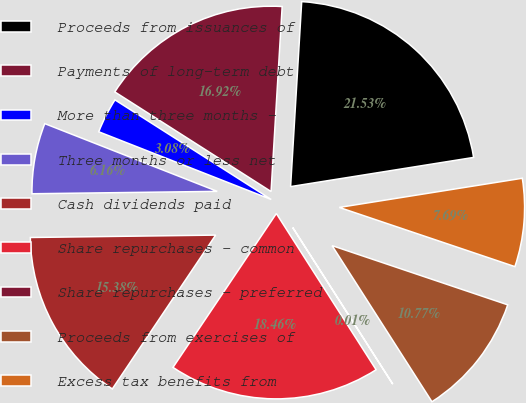<chart> <loc_0><loc_0><loc_500><loc_500><pie_chart><fcel>Proceeds from issuances of<fcel>Payments of long-term debt<fcel>More than three months -<fcel>Three months or less net<fcel>Cash dividends paid<fcel>Share repurchases - common<fcel>Share repurchases - preferred<fcel>Proceeds from exercises of<fcel>Excess tax benefits from<nl><fcel>21.53%<fcel>16.92%<fcel>3.08%<fcel>6.16%<fcel>15.38%<fcel>18.46%<fcel>0.01%<fcel>10.77%<fcel>7.69%<nl></chart> 